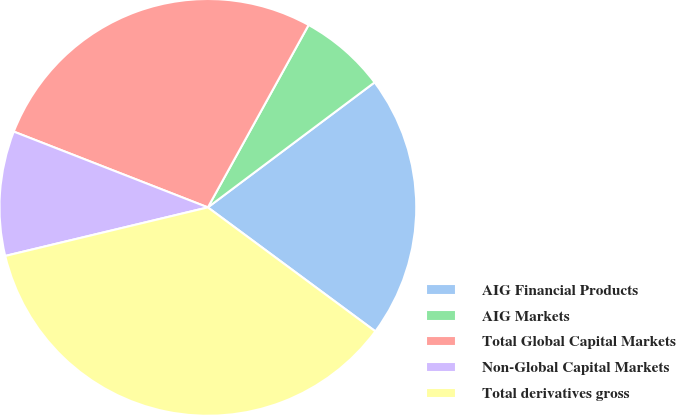<chart> <loc_0><loc_0><loc_500><loc_500><pie_chart><fcel>AIG Financial Products<fcel>AIG Markets<fcel>Total Global Capital Markets<fcel>Non-Global Capital Markets<fcel>Total derivatives gross<nl><fcel>20.38%<fcel>6.73%<fcel>27.11%<fcel>9.67%<fcel>36.12%<nl></chart> 